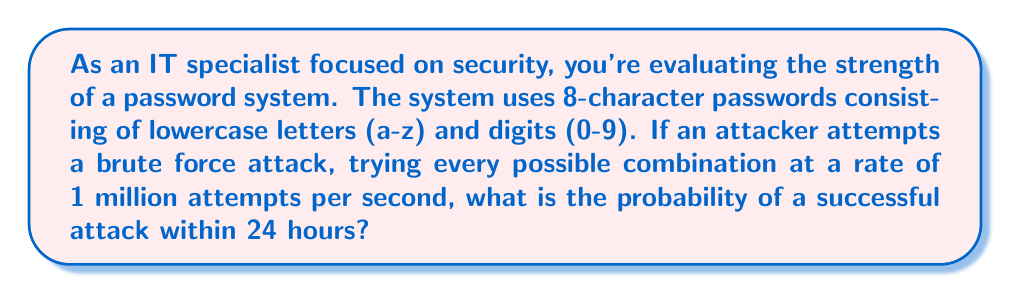Give your solution to this math problem. Let's approach this step-by-step:

1) First, we need to calculate the total number of possible passwords:
   - There are 26 lowercase letters and 10 digits, so 36 possible characters for each position.
   - The password is 8 characters long.
   - Total combinations: $36^8 = 2,821,109,907,456$

2) Now, let's calculate how many attempts the attacker can make in 24 hours:
   - Attempts per second: 1,000,000
   - Seconds in 24 hours: $24 * 60 * 60 = 86,400$
   - Total attempts in 24 hours: $86,400 * 1,000,000 = 86,400,000,000$

3) The probability of success is the number of attempts divided by the total number of possibilities:

   $$P(\text{success}) = \frac{\text{Number of attempts}}{\text{Total possibilities}}$$

   $$P(\text{success}) = \frac{86,400,000,000}{2,821,109,907,456}$$

4) Simplifying this fraction:

   $$P(\text{success}) \approx 0.0306$$

5) Convert to percentage:

   $$P(\text{success}) \approx 3.06\%$$
Answer: The probability of a successful brute force attack within 24 hours is approximately $3.06\%$. 